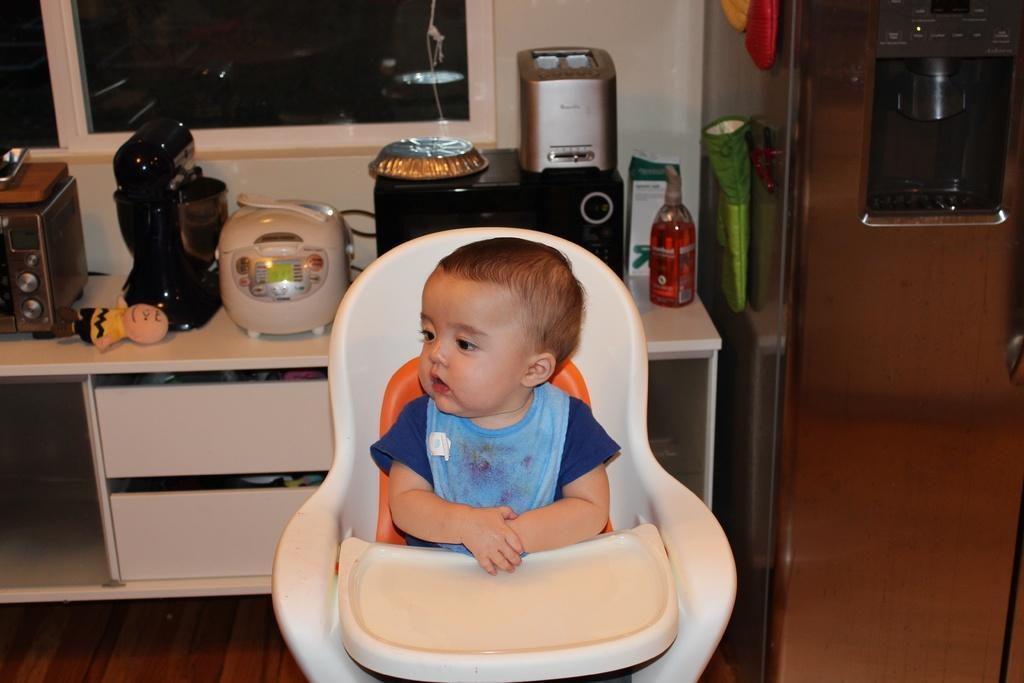How would you summarize this image in a sentence or two? In this image there is a child seated in his chair, behind the child there are a few objects on the table. 